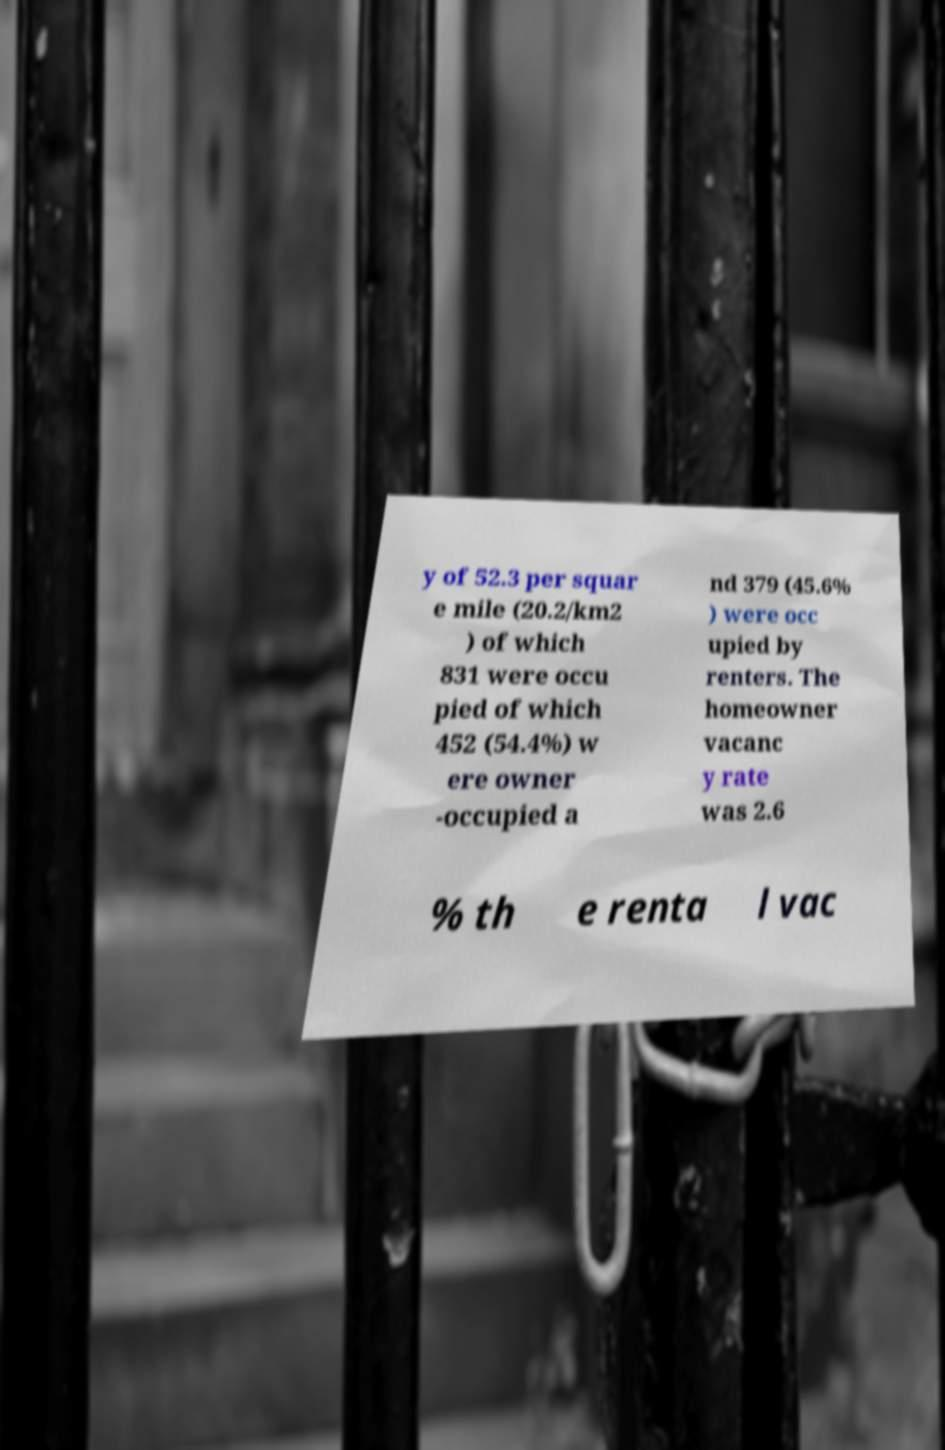Please read and relay the text visible in this image. What does it say? y of 52.3 per squar e mile (20.2/km2 ) of which 831 were occu pied of which 452 (54.4%) w ere owner -occupied a nd 379 (45.6% ) were occ upied by renters. The homeowner vacanc y rate was 2.6 % th e renta l vac 